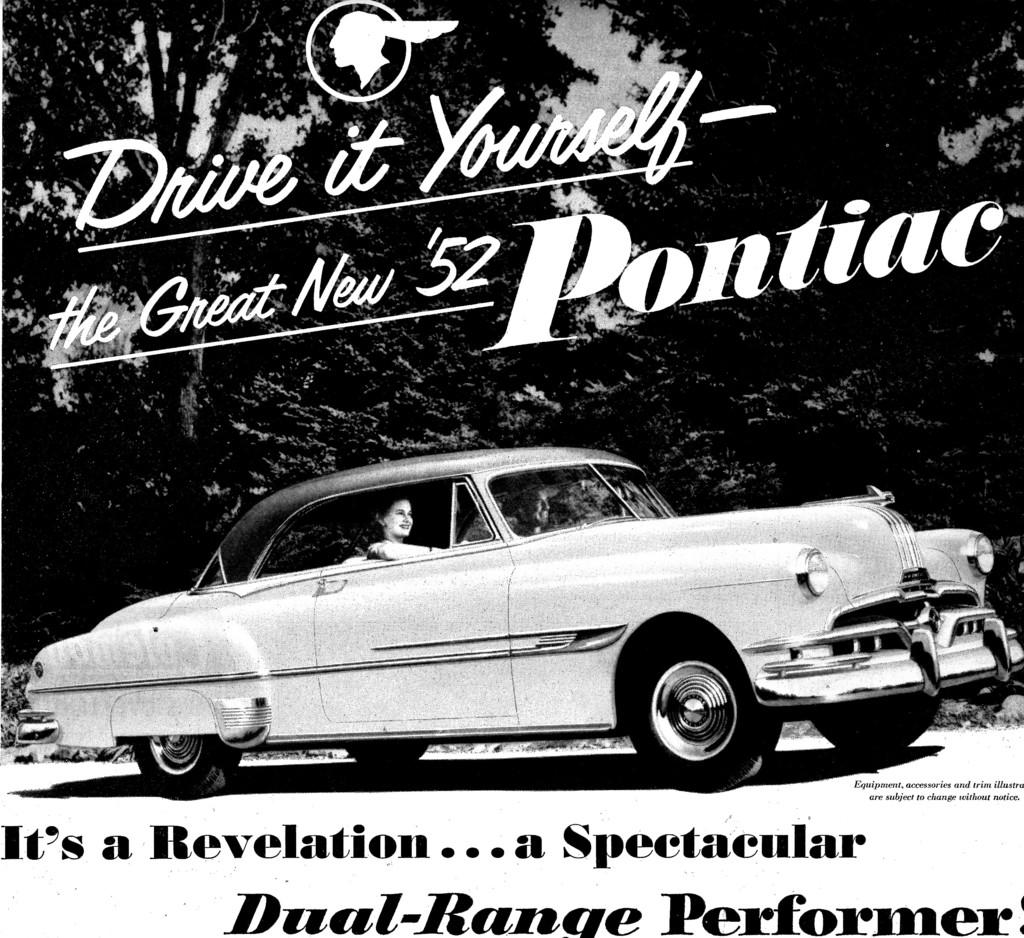How many people are in the car in the image? There are two persons in a car in the image. What is visible behind the car? There is a group of trees behind the car. What can be seen at the top of the image? The sky is visible at the top of the image. Are there any words or letters in the image? Yes, there is text at the top and bottom of the image. What type of appliance can be seen in the car with the two persons? There is no appliance visible in the car with the two persons; the image only shows the car and the people inside. 